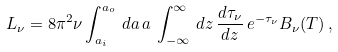Convert formula to latex. <formula><loc_0><loc_0><loc_500><loc_500>L _ { \nu } = 8 \pi ^ { 2 } \nu \int _ { a _ { i } } ^ { a _ { o } } \, d a \, a \, \int _ { - \infty } ^ { \infty } \, d z \, \frac { d \tau _ { \nu } } { d z } \, e ^ { - \tau _ { \nu } } B _ { \nu } ( T ) \, ,</formula> 